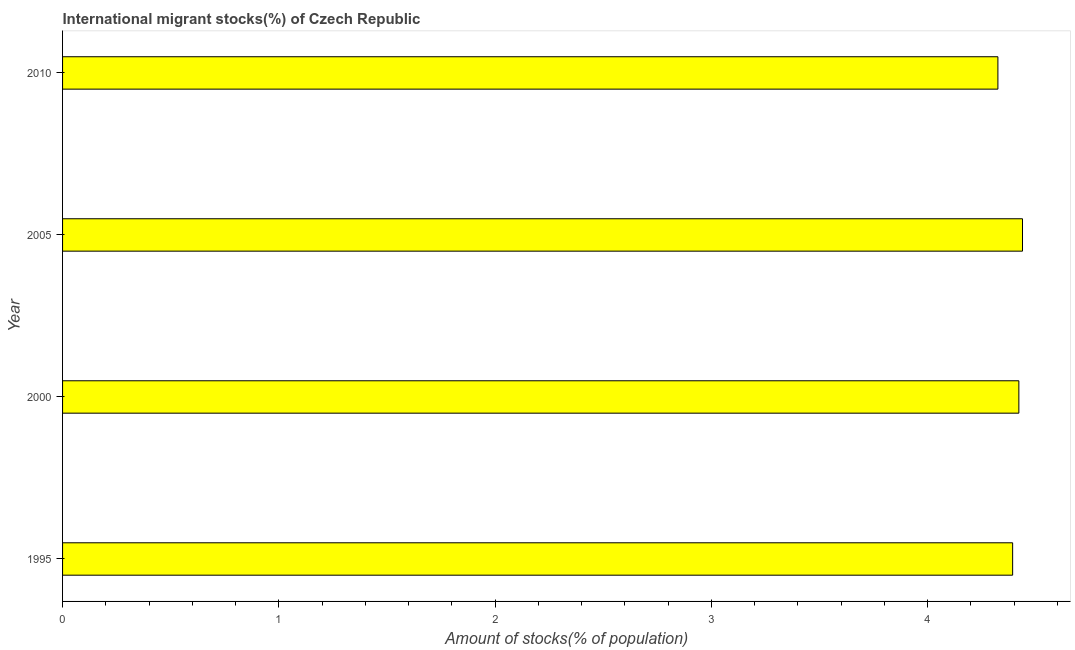Does the graph contain any zero values?
Your answer should be compact. No. What is the title of the graph?
Keep it short and to the point. International migrant stocks(%) of Czech Republic. What is the label or title of the X-axis?
Provide a succinct answer. Amount of stocks(% of population). What is the number of international migrant stocks in 1995?
Give a very brief answer. 4.39. Across all years, what is the maximum number of international migrant stocks?
Provide a succinct answer. 4.44. Across all years, what is the minimum number of international migrant stocks?
Offer a very short reply. 4.33. In which year was the number of international migrant stocks minimum?
Offer a terse response. 2010. What is the sum of the number of international migrant stocks?
Your answer should be very brief. 17.58. What is the difference between the number of international migrant stocks in 2000 and 2010?
Give a very brief answer. 0.1. What is the average number of international migrant stocks per year?
Offer a terse response. 4.39. What is the median number of international migrant stocks?
Make the answer very short. 4.41. In how many years, is the number of international migrant stocks greater than 0.2 %?
Your answer should be very brief. 4. Is the number of international migrant stocks in 1995 less than that in 2000?
Provide a succinct answer. Yes. What is the difference between the highest and the second highest number of international migrant stocks?
Provide a short and direct response. 0.02. What is the difference between the highest and the lowest number of international migrant stocks?
Provide a succinct answer. 0.11. Are all the bars in the graph horizontal?
Ensure brevity in your answer.  Yes. How many years are there in the graph?
Offer a very short reply. 4. What is the difference between two consecutive major ticks on the X-axis?
Give a very brief answer. 1. What is the Amount of stocks(% of population) in 1995?
Ensure brevity in your answer.  4.39. What is the Amount of stocks(% of population) of 2000?
Ensure brevity in your answer.  4.42. What is the Amount of stocks(% of population) of 2005?
Provide a succinct answer. 4.44. What is the Amount of stocks(% of population) of 2010?
Provide a short and direct response. 4.33. What is the difference between the Amount of stocks(% of population) in 1995 and 2000?
Your answer should be compact. -0.03. What is the difference between the Amount of stocks(% of population) in 1995 and 2005?
Give a very brief answer. -0.05. What is the difference between the Amount of stocks(% of population) in 1995 and 2010?
Give a very brief answer. 0.07. What is the difference between the Amount of stocks(% of population) in 2000 and 2005?
Your answer should be compact. -0.02. What is the difference between the Amount of stocks(% of population) in 2000 and 2010?
Give a very brief answer. 0.1. What is the difference between the Amount of stocks(% of population) in 2005 and 2010?
Provide a succinct answer. 0.11. What is the ratio of the Amount of stocks(% of population) in 1995 to that in 2005?
Provide a short and direct response. 0.99. What is the ratio of the Amount of stocks(% of population) in 1995 to that in 2010?
Offer a very short reply. 1.02. What is the ratio of the Amount of stocks(% of population) in 2000 to that in 2010?
Provide a short and direct response. 1.02. 